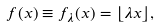<formula> <loc_0><loc_0><loc_500><loc_500>f ( x ) \equiv f _ { \lambda } ( x ) = \lfloor \lambda x \rfloor ,</formula> 